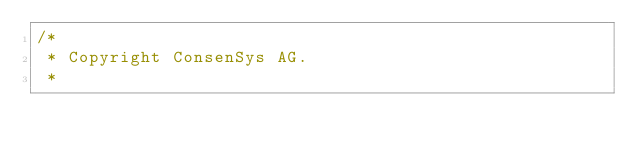Convert code to text. <code><loc_0><loc_0><loc_500><loc_500><_Java_>/*
 * Copyright ConsenSys AG.
 *</code> 